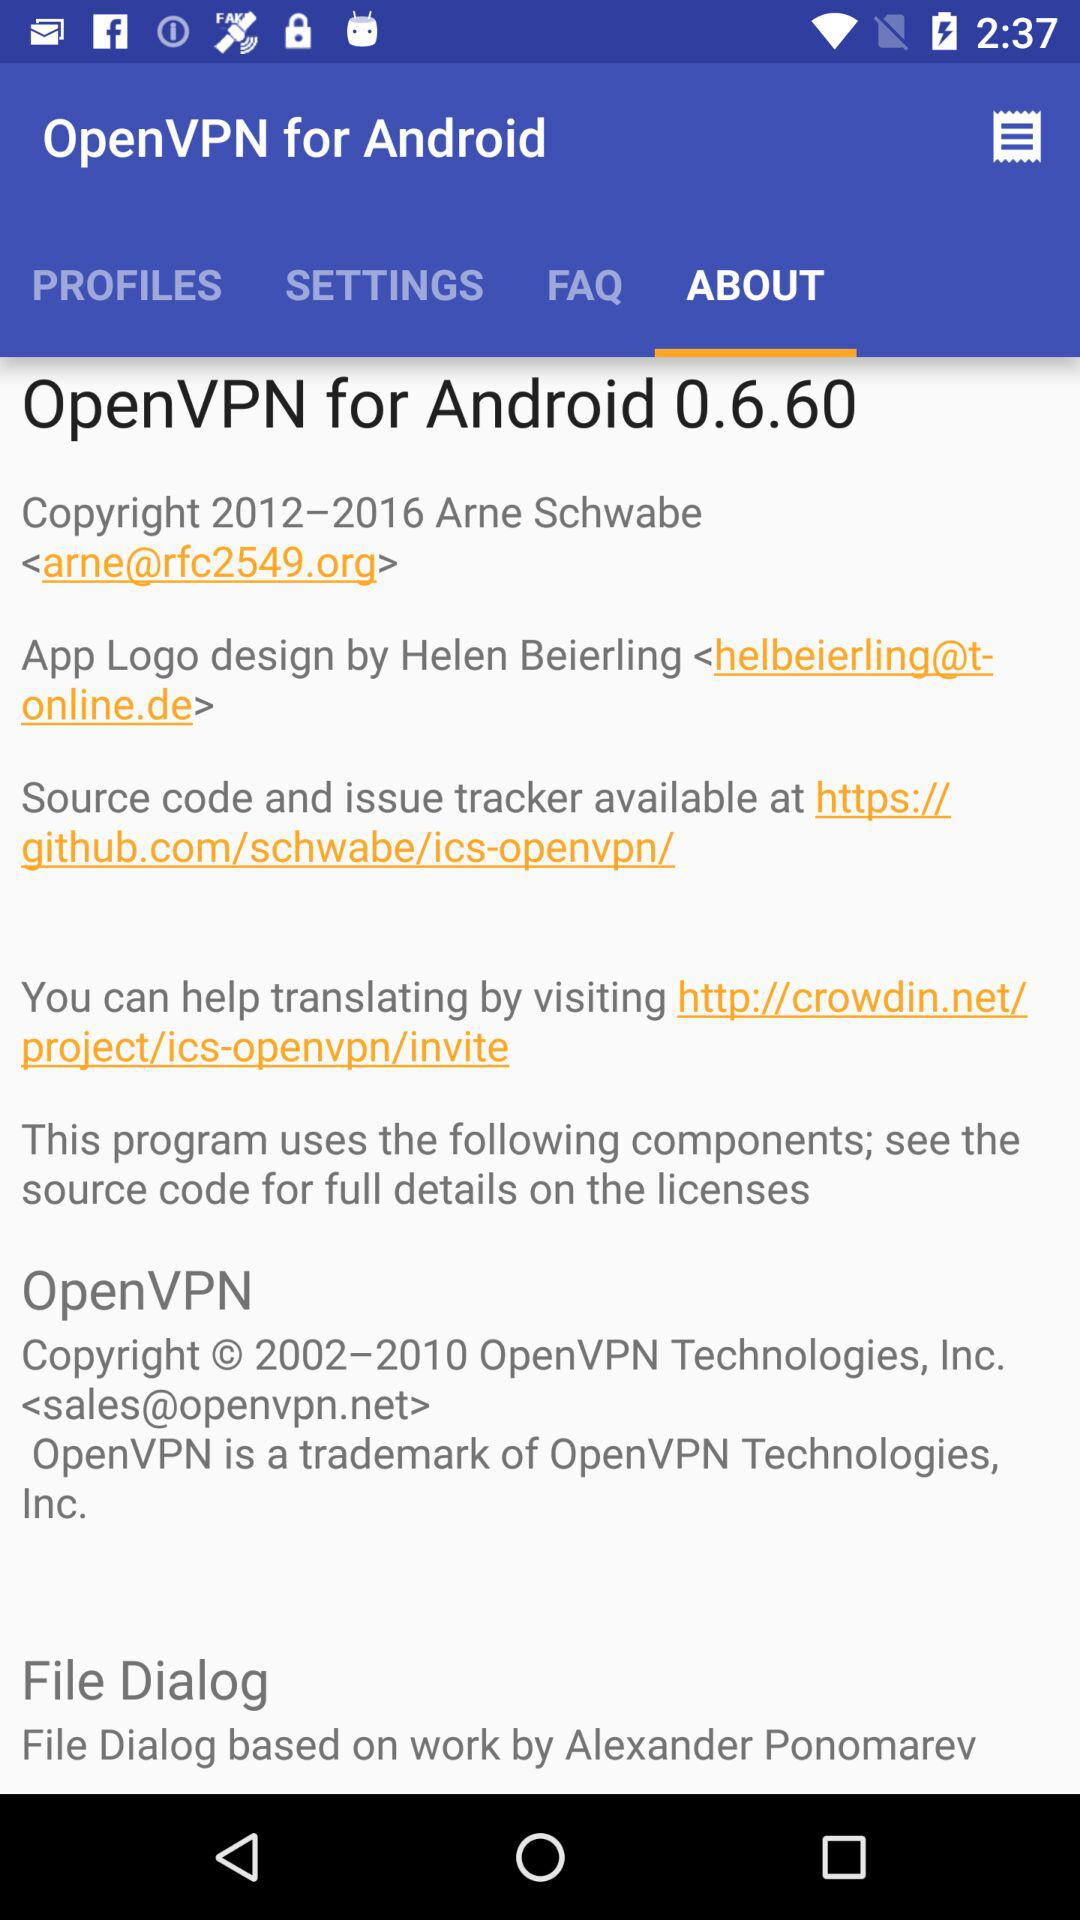What is Arne Schwabe's phone number?
When the provided information is insufficient, respond with <no answer>. <no answer> 